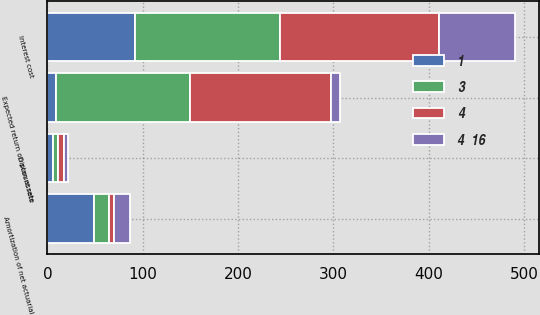Convert chart. <chart><loc_0><loc_0><loc_500><loc_500><stacked_bar_chart><ecel><fcel>Interest cost<fcel>Expected return on plan assets<fcel>Amortization of net actuarial<fcel>Discount rate<nl><fcel>3<fcel>152<fcel>141<fcel>16<fcel>5.2<nl><fcel>4<fcel>167<fcel>148<fcel>5<fcel>6<nl><fcel>4  16<fcel>80<fcel>9<fcel>17<fcel>5.1<nl><fcel>1<fcel>92<fcel>9<fcel>49<fcel>5.75<nl></chart> 